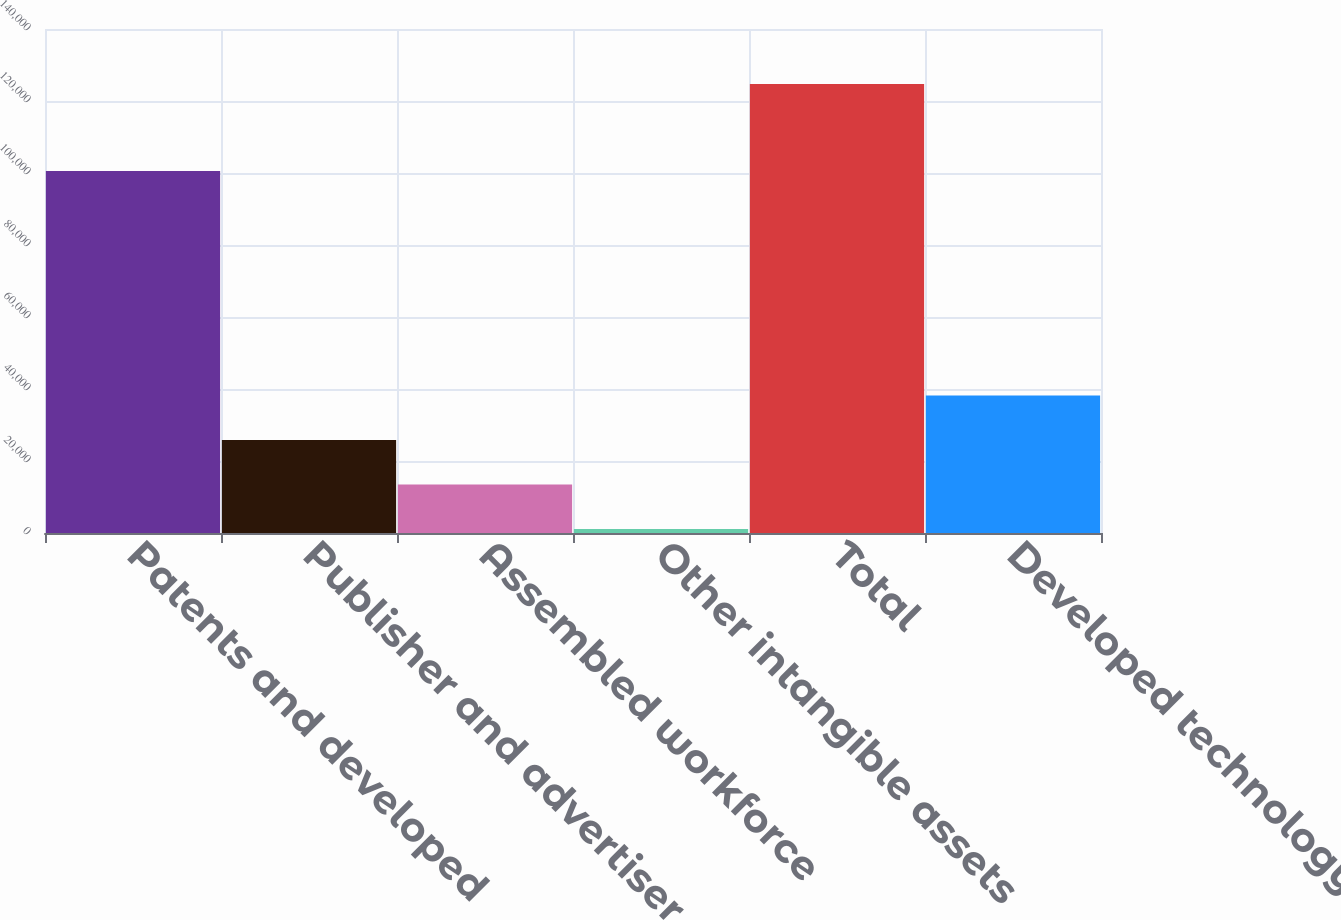Convert chart. <chart><loc_0><loc_0><loc_500><loc_500><bar_chart><fcel>Patents and developed<fcel>Publisher and advertiser<fcel>Assembled workforce<fcel>Other intangible assets<fcel>Total<fcel>Developed technology<nl><fcel>100553<fcel>25822.6<fcel>13461.3<fcel>1100<fcel>124713<fcel>38183.9<nl></chart> 